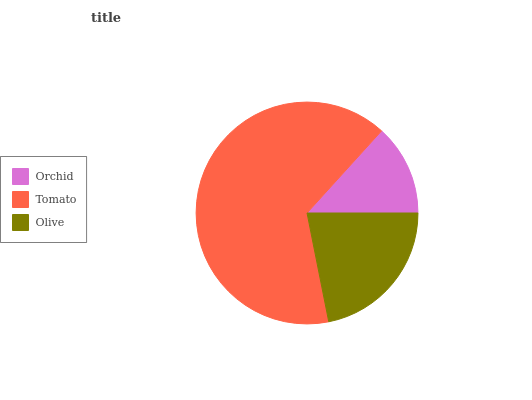Is Orchid the minimum?
Answer yes or no. Yes. Is Tomato the maximum?
Answer yes or no. Yes. Is Olive the minimum?
Answer yes or no. No. Is Olive the maximum?
Answer yes or no. No. Is Tomato greater than Olive?
Answer yes or no. Yes. Is Olive less than Tomato?
Answer yes or no. Yes. Is Olive greater than Tomato?
Answer yes or no. No. Is Tomato less than Olive?
Answer yes or no. No. Is Olive the high median?
Answer yes or no. Yes. Is Olive the low median?
Answer yes or no. Yes. Is Tomato the high median?
Answer yes or no. No. Is Tomato the low median?
Answer yes or no. No. 